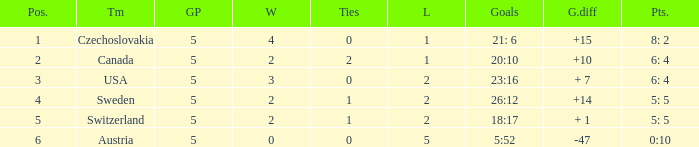What was the largest tie when the G.P was more than 5? None. 